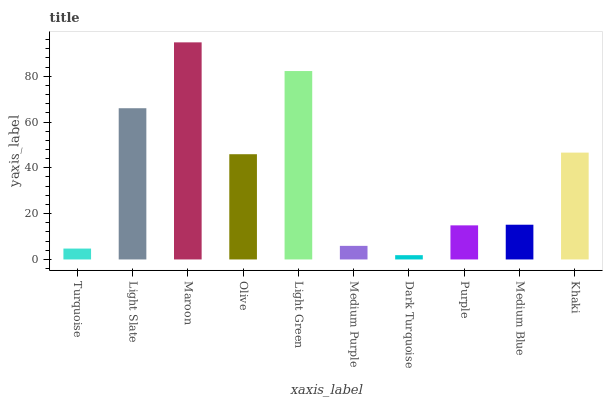Is Dark Turquoise the minimum?
Answer yes or no. Yes. Is Maroon the maximum?
Answer yes or no. Yes. Is Light Slate the minimum?
Answer yes or no. No. Is Light Slate the maximum?
Answer yes or no. No. Is Light Slate greater than Turquoise?
Answer yes or no. Yes. Is Turquoise less than Light Slate?
Answer yes or no. Yes. Is Turquoise greater than Light Slate?
Answer yes or no. No. Is Light Slate less than Turquoise?
Answer yes or no. No. Is Olive the high median?
Answer yes or no. Yes. Is Medium Blue the low median?
Answer yes or no. Yes. Is Maroon the high median?
Answer yes or no. No. Is Maroon the low median?
Answer yes or no. No. 